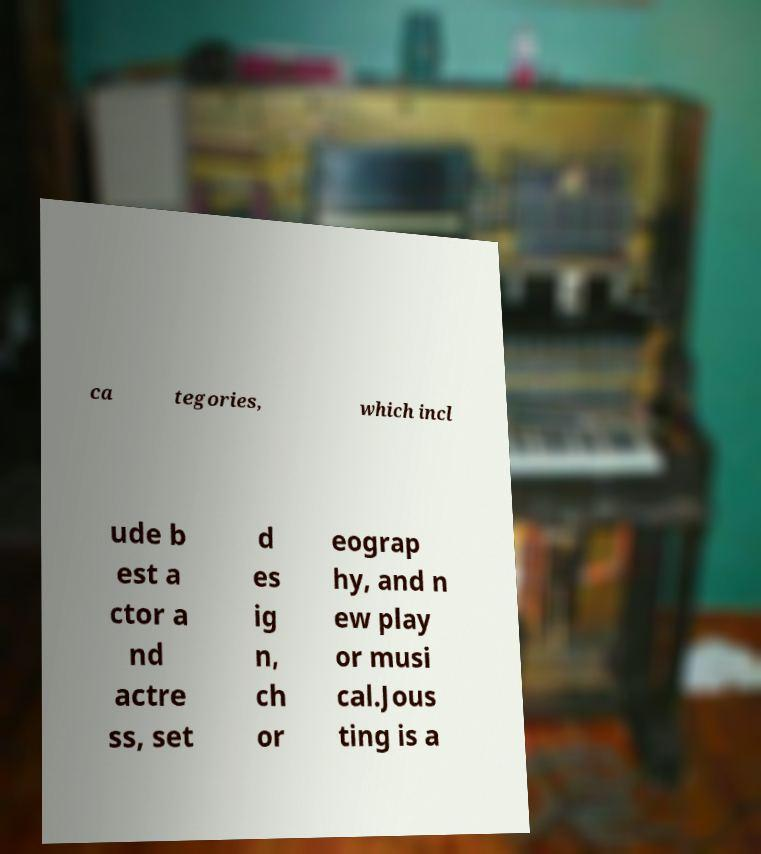Can you read and provide the text displayed in the image?This photo seems to have some interesting text. Can you extract and type it out for me? ca tegories, which incl ude b est a ctor a nd actre ss, set d es ig n, ch or eograp hy, and n ew play or musi cal.Jous ting is a 